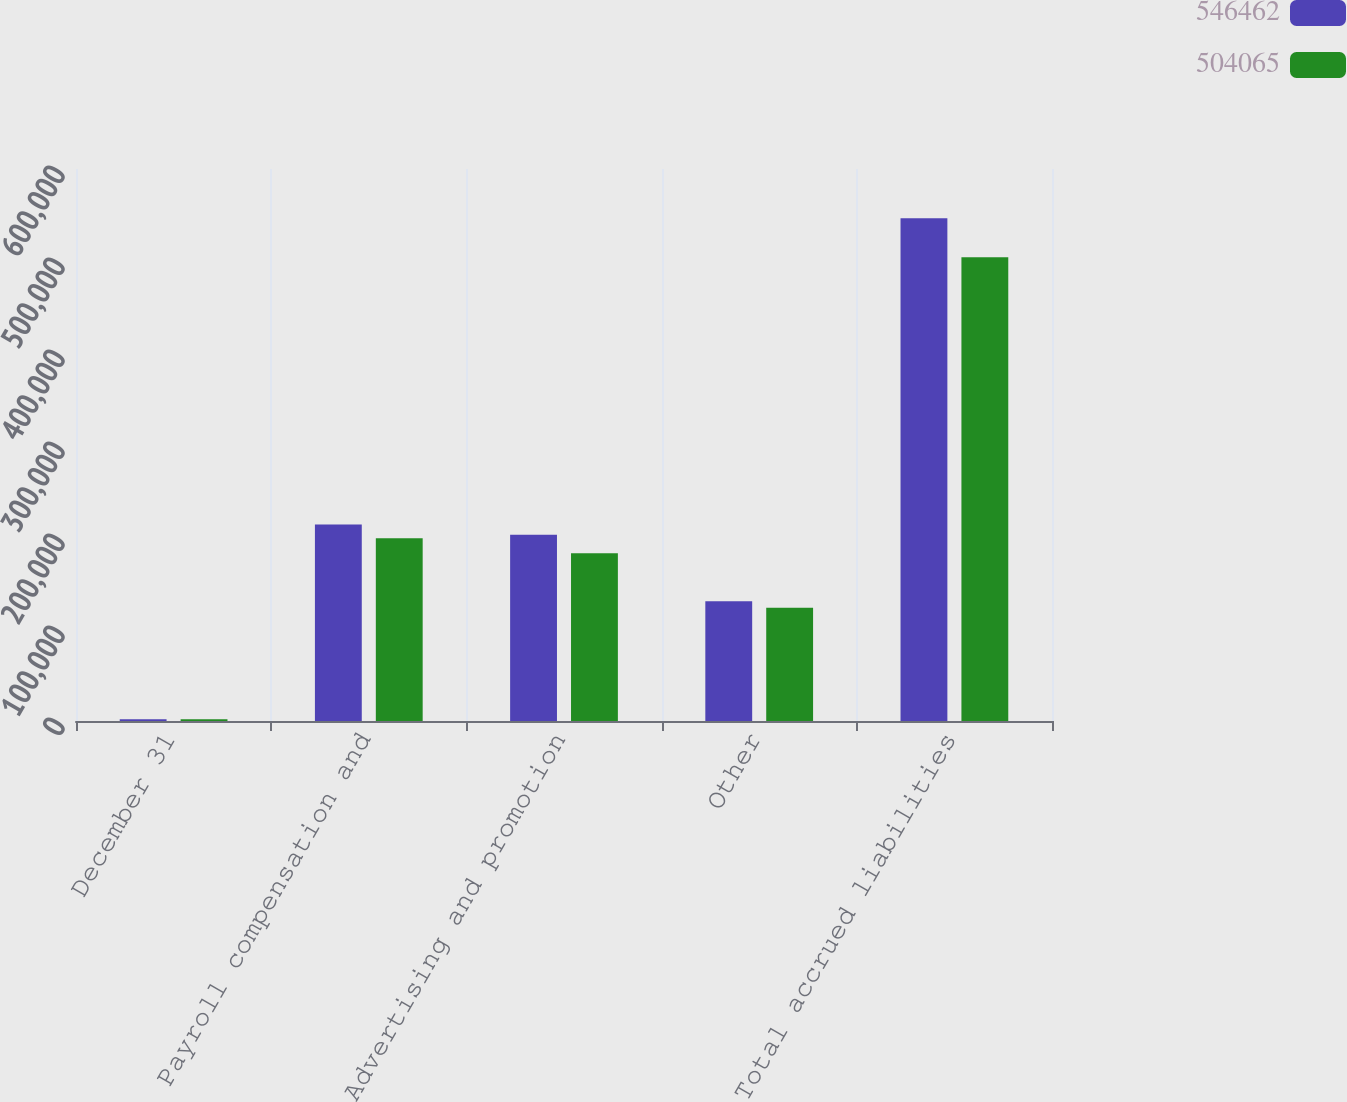Convert chart to OTSL. <chart><loc_0><loc_0><loc_500><loc_500><stacked_bar_chart><ecel><fcel>December 31<fcel>Payroll compensation and<fcel>Advertising and promotion<fcel>Other<fcel>Total accrued liabilities<nl><fcel>546462<fcel>2009<fcel>213715<fcel>202547<fcel>130200<fcel>546462<nl><fcel>504065<fcel>2008<fcel>198710<fcel>182227<fcel>123128<fcel>504065<nl></chart> 